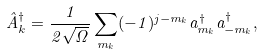<formula> <loc_0><loc_0><loc_500><loc_500>\hat { A } ^ { \dag } _ { k } = \frac { 1 } { 2 \sqrt { \Omega } } \sum _ { m _ { k } } ( - 1 ) ^ { j - m _ { k } } a ^ { \dag } _ { m _ { k } } a ^ { \dag } _ { - m _ { k } } ,</formula> 